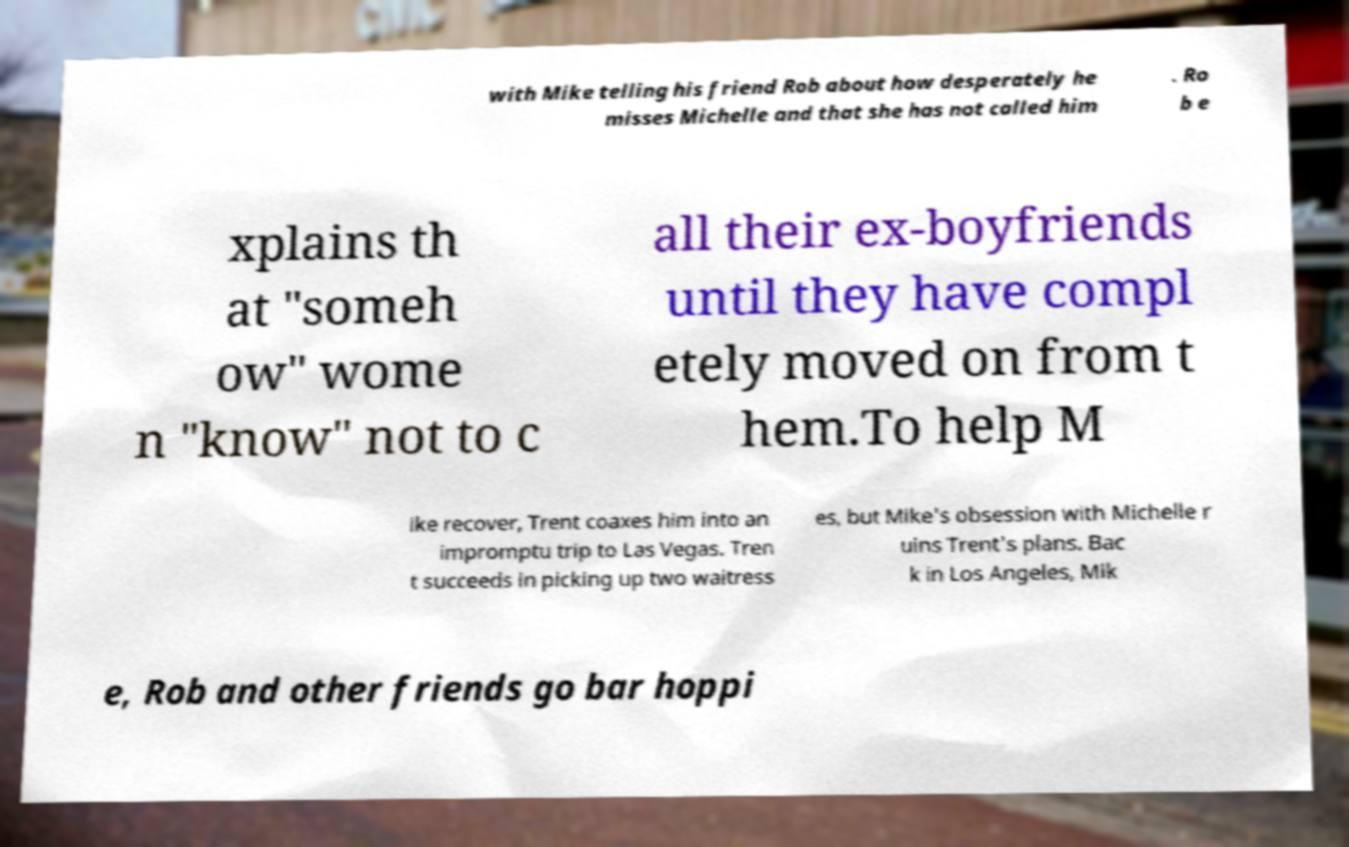Could you assist in decoding the text presented in this image and type it out clearly? with Mike telling his friend Rob about how desperately he misses Michelle and that she has not called him . Ro b e xplains th at "someh ow" wome n "know" not to c all their ex-boyfriends until they have compl etely moved on from t hem.To help M ike recover, Trent coaxes him into an impromptu trip to Las Vegas. Tren t succeeds in picking up two waitress es, but Mike's obsession with Michelle r uins Trent's plans. Bac k in Los Angeles, Mik e, Rob and other friends go bar hoppi 